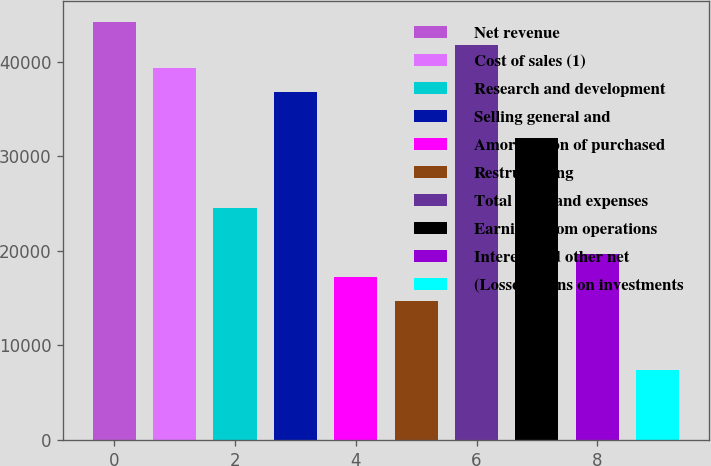Convert chart to OTSL. <chart><loc_0><loc_0><loc_500><loc_500><bar_chart><fcel>Net revenue<fcel>Cost of sales (1)<fcel>Research and development<fcel>Selling general and<fcel>Amortization of purchased<fcel>Restructuring<fcel>Total costs and expenses<fcel>Earnings from operations<fcel>Interest and other net<fcel>(Losses) gains on investments<nl><fcel>44198.9<fcel>39287.9<fcel>24555<fcel>36832.4<fcel>17188.5<fcel>14733<fcel>41743.4<fcel>31921.5<fcel>19644<fcel>7366.55<nl></chart> 